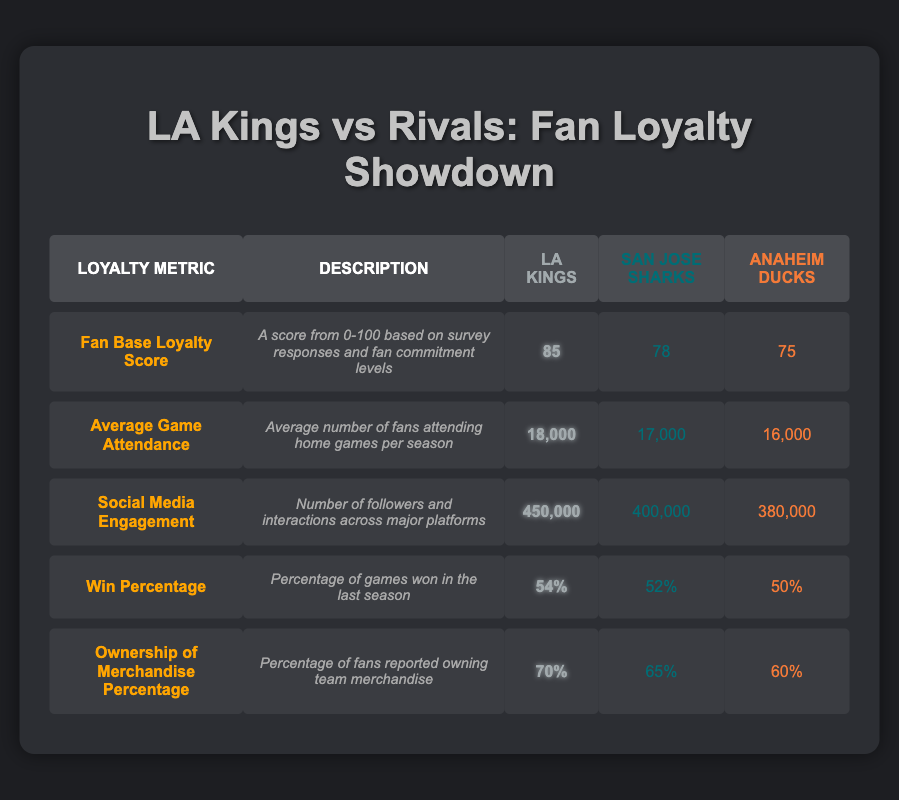What is the Fan Base Loyalty Score for the Los Angeles Kings? According to the table, the Fan Base Loyalty Score for the Los Angeles Kings is listed under the "LA Kings" column in the "Fan Base Loyalty Score" row, which is 85.
Answer: 85 What is the average game attendance for the San Jose Sharks? The average game attendance for the San Jose Sharks is found in the "Average Game Attendance" row under the "San Jose Sharks" column, which shows a value of 17,000.
Answer: 17,000 Is the win percentage of the Anaheim Ducks greater than or equal to the LA Kings? The win percentage for the Anaheim Ducks is listed under the "Win Percentage" row as 50%, while the LA Kings have a win percentage of 54%. Since 50% is less than 54%, the statement is false.
Answer: No What is the difference in social media engagement between the Los Angeles Kings and the Anaheim Ducks? To find the difference in social media engagement, subtract the engagement of the Anaheim Ducks (380,000) from that of the Los Angeles Kings (450,000). The calculation is 450,000 - 380,000 = 70,000.
Answer: 70,000 Which team has the highest ownership of merchandise percentage? The ownership of merchandise percentage can be found in the "Ownership of Merchandise Percentage" row. The percentage for the La Kings is 70%, the Sharks is 65%, and the Ducks is 60%. The highest percentage is 70%, which belongs to the Los Angeles Kings.
Answer: Los Angeles Kings What is the average of the fan base loyalty scores for all three teams? To calculate the average fan base loyalty score, first sum the scores: 85 (Kings) + 78 (Sharks) + 75 (Ducks) = 238. Then divide the total by the number of teams: 238 / 3 = 79.33.
Answer: 79.33 Do the San Jose Sharks have a higher average game attendance than the Anaheim Ducks? The average game attendance for the San Jose Sharks is 17,000, while for the Anaheim Ducks, it is 16,000. Since 17,000 is greater than 16,000, the statement is true.
Answer: Yes What is the total ownership of merchandise percentage for the three teams combined? The total ownership of merchandise percentage can be calculated by summing the individual percentages: 70% (Kings) + 65% (Sharks) + 60% (Ducks) = 195%.
Answer: 195% Which team has the lowest social media engagement? The social media engagement numbers are 450,000 (Kings), 400,000 (Sharks), and 380,000 (Ducks). The lowest engagement is 380,000, which belongs to the Anaheim Ducks.
Answer: Anaheim Ducks 